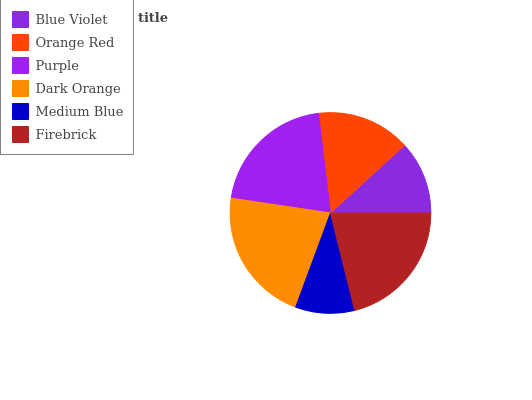Is Medium Blue the minimum?
Answer yes or no. Yes. Is Dark Orange the maximum?
Answer yes or no. Yes. Is Orange Red the minimum?
Answer yes or no. No. Is Orange Red the maximum?
Answer yes or no. No. Is Orange Red greater than Blue Violet?
Answer yes or no. Yes. Is Blue Violet less than Orange Red?
Answer yes or no. Yes. Is Blue Violet greater than Orange Red?
Answer yes or no. No. Is Orange Red less than Blue Violet?
Answer yes or no. No. Is Purple the high median?
Answer yes or no. Yes. Is Orange Red the low median?
Answer yes or no. Yes. Is Blue Violet the high median?
Answer yes or no. No. Is Firebrick the low median?
Answer yes or no. No. 